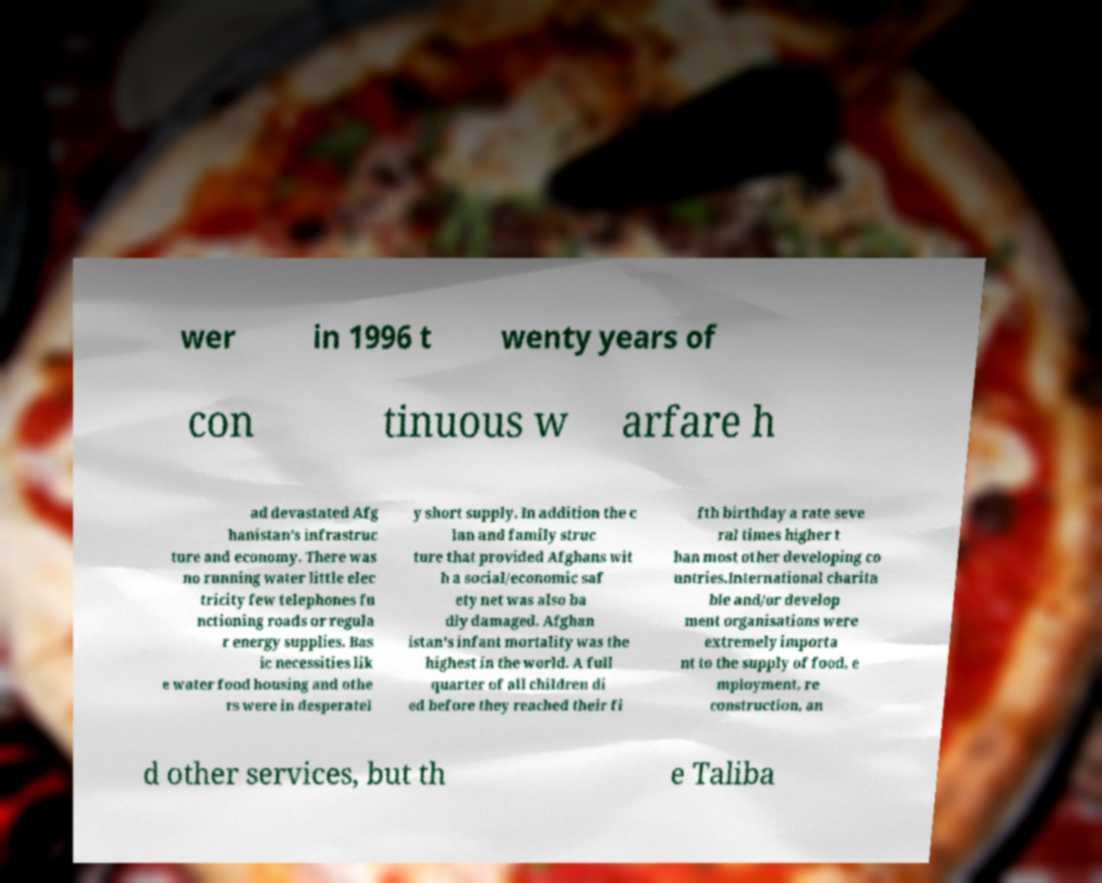Could you extract and type out the text from this image? wer in 1996 t wenty years of con tinuous w arfare h ad devastated Afg hanistan's infrastruc ture and economy. There was no running water little elec tricity few telephones fu nctioning roads or regula r energy supplies. Bas ic necessities lik e water food housing and othe rs were in desperatel y short supply. In addition the c lan and family struc ture that provided Afghans wit h a social/economic saf ety net was also ba dly damaged. Afghan istan's infant mortality was the highest in the world. A full quarter of all children di ed before they reached their fi fth birthday a rate seve ral times higher t han most other developing co untries.International charita ble and/or develop ment organisations were extremely importa nt to the supply of food, e mployment, re construction, an d other services, but th e Taliba 